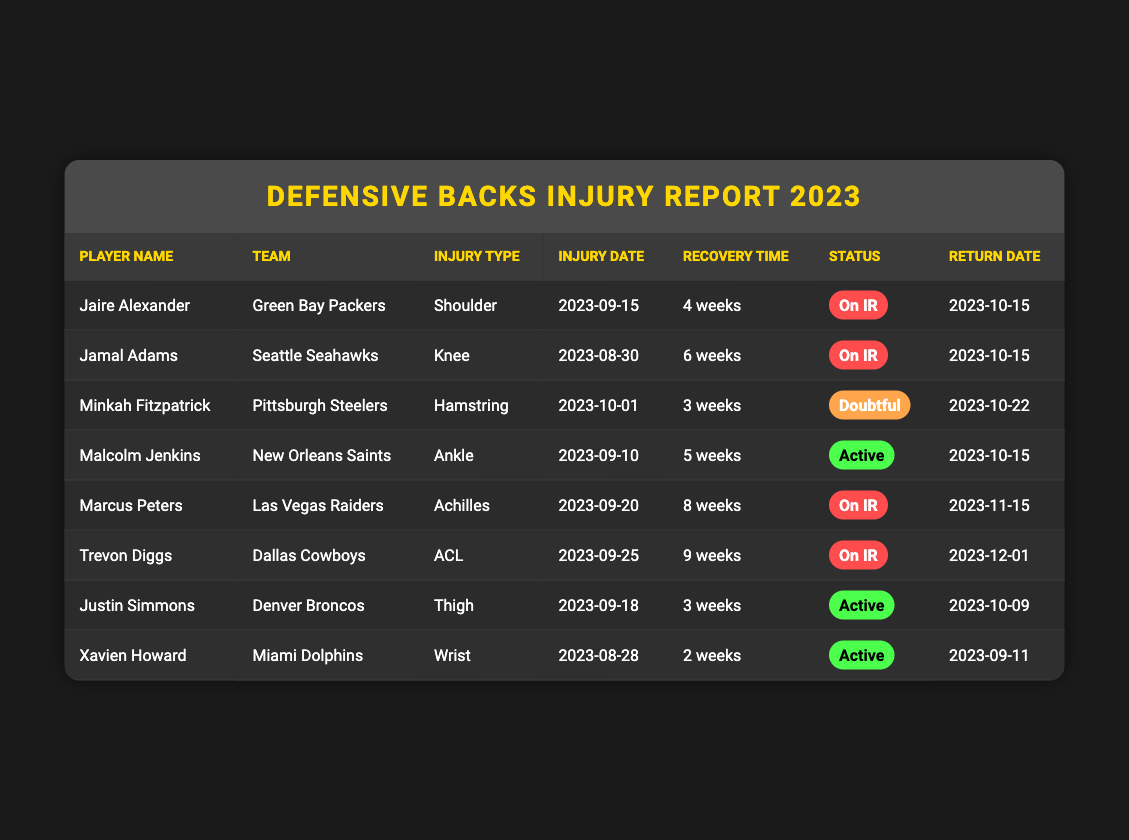What is the injury type for Jaire Alexander? Jaire Alexander's injury type is listed in the table under "Injury Type," which states it is a "Shoulder."
Answer: Shoulder How many weeks of recovery time does Jamal Adams need? The table indicates that Jamal Adams has a recovery time of "6 weeks" listed under "Recovery Time."
Answer: 6 weeks Which player has the longest recovery time? By reviewing the "Recovery Time" column, I see that Trevon Diggs has the longest recovery time of "9 weeks."
Answer: Trevon Diggs What is the return date for Malcolm Jenkins? The return date is provided in the table under "Return Date," which shows it is "2023-10-15."
Answer: 2023-10-15 Are any of the players currently active? By checking the "Status" column, I can see that Malcolm Jenkins, Justin Simmons, and Xavien Howard are labeled as "Active."
Answer: Yes How many players are on IR? I will count the players listed as "On IR" in the "Status" column, finding Jaire Alexander, Jamal Adams, Marcus Peters, and Trevon Diggs, which totals 4 players.
Answer: 4 players What is the average recovery time of all players listed? To find the average, I need to sum the recovery times (4 + 6 + 3 + 5 + 8 + 9 + 3 + 2 = 40 weeks) and divide by the number of players (8), which gives 40/8 = 5 weeks.
Answer: 5 weeks Is Xavien Howard returning before Marcus Peters? Comparing the return dates, Xavien Howard's is "2023-09-11" and Marcus Peters' is "2023-11-15," showing that Howard will return first.
Answer: Yes Which team does Minkah Fitzpatrick play for? Looking under the "Team" column, Minkah Fitzpatrick plays for the "Pittsburgh Steelers."
Answer: Pittsburgh Steelers What is the injury date for Trevon Diggs? The "Injury Date" column specifies that Trevon Diggs' injury date is "2023-09-25."
Answer: 2023-09-25 